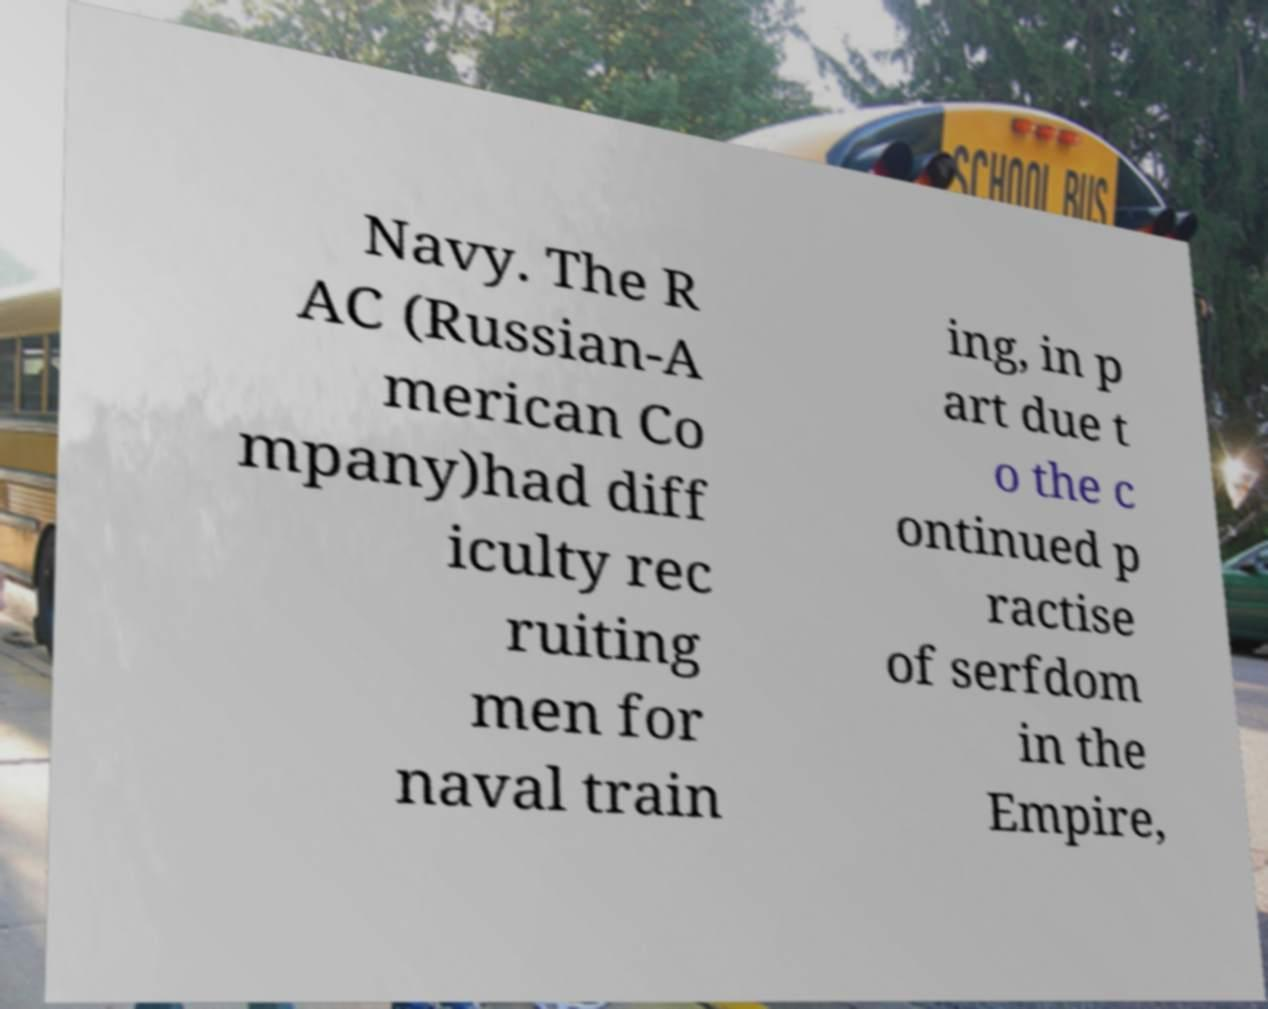Can you read and provide the text displayed in the image?This photo seems to have some interesting text. Can you extract and type it out for me? Navy. The R AC (Russian-A merican Co mpany)had diff iculty rec ruiting men for naval train ing, in p art due t o the c ontinued p ractise of serfdom in the Empire, 